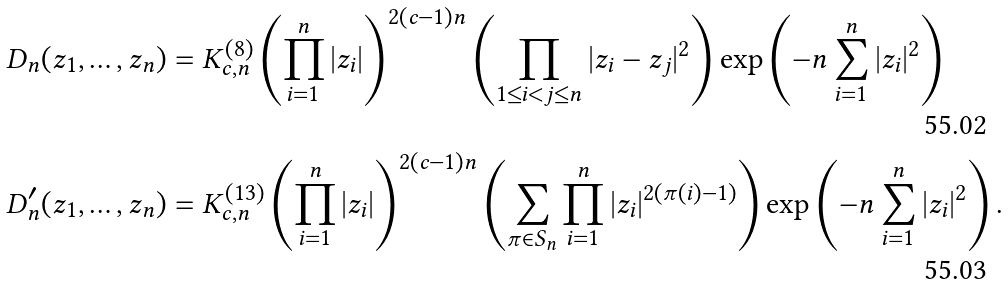Convert formula to latex. <formula><loc_0><loc_0><loc_500><loc_500>D _ { n } ( z _ { 1 } , \dots , z _ { n } ) & = K _ { c , n } ^ { ( 8 ) } \left ( \prod _ { i = 1 } ^ { n } | z _ { i } | \right ) ^ { 2 ( c - 1 ) n } \left ( \prod _ { 1 \leq i < j \leq n } | z _ { i } - z _ { j } | ^ { 2 } \right ) \exp \left ( - n \sum _ { i = 1 } ^ { n } | z _ { i } | ^ { 2 } \right ) \\ D _ { n } ^ { \prime } ( z _ { 1 } , \dots , z _ { n } ) & = K _ { c , n } ^ { ( 1 3 ) } \left ( \prod _ { i = 1 } ^ { n } | z _ { i } | \right ) ^ { 2 ( c - 1 ) n } \left ( \sum _ { \pi \in S _ { n } } \prod _ { i = 1 } ^ { n } | z _ { i } | ^ { 2 ( \pi ( i ) - 1 ) } \right ) \exp \left ( - n \sum _ { i = 1 } ^ { n } | z _ { i } | ^ { 2 } \right ) .</formula> 